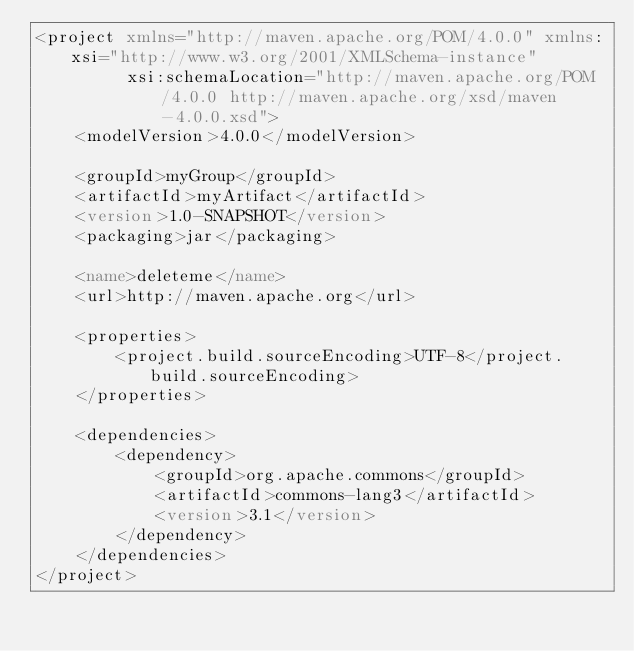Convert code to text. <code><loc_0><loc_0><loc_500><loc_500><_XML_><project xmlns="http://maven.apache.org/POM/4.0.0" xmlns:xsi="http://www.w3.org/2001/XMLSchema-instance"
         xsi:schemaLocation="http://maven.apache.org/POM/4.0.0 http://maven.apache.org/xsd/maven-4.0.0.xsd">
    <modelVersion>4.0.0</modelVersion>

    <groupId>myGroup</groupId>
    <artifactId>myArtifact</artifactId>
    <version>1.0-SNAPSHOT</version>
    <packaging>jar</packaging>

    <name>deleteme</name>
    <url>http://maven.apache.org</url>

    <properties>
        <project.build.sourceEncoding>UTF-8</project.build.sourceEncoding>
    </properties>

    <dependencies>
        <dependency>
            <groupId>org.apache.commons</groupId>
            <artifactId>commons-lang3</artifactId>
            <version>3.1</version>
        </dependency>
    </dependencies>
</project></code> 